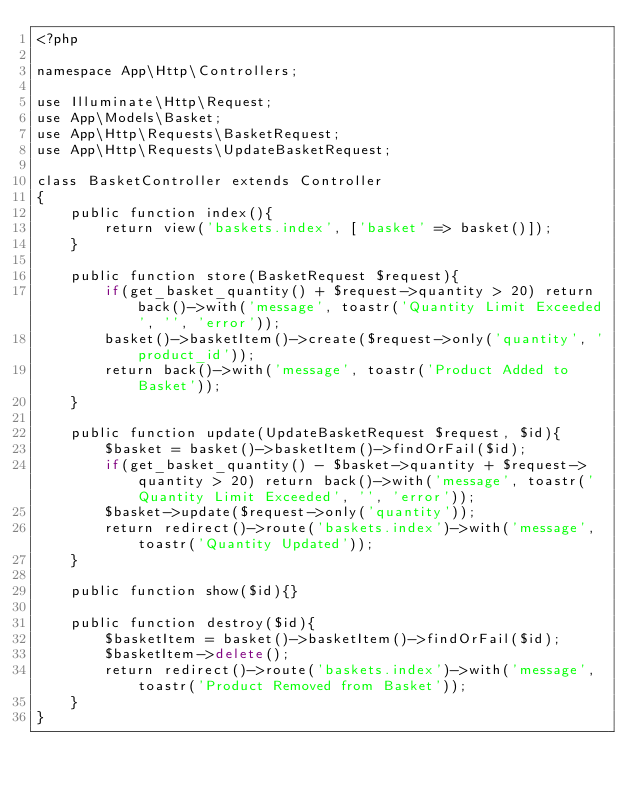<code> <loc_0><loc_0><loc_500><loc_500><_PHP_><?php

namespace App\Http\Controllers;

use Illuminate\Http\Request;
use App\Models\Basket;
use App\Http\Requests\BasketRequest;
use App\Http\Requests\UpdateBasketRequest;

class BasketController extends Controller
{
    public function index(){
        return view('baskets.index', ['basket' => basket()]);
    }

    public function store(BasketRequest $request){
        if(get_basket_quantity() + $request->quantity > 20) return back()->with('message', toastr('Quantity Limit Exceeded', '', 'error'));
        basket()->basketItem()->create($request->only('quantity', 'product_id'));
        return back()->with('message', toastr('Product Added to Basket'));
    }

    public function update(UpdateBasketRequest $request, $id){
        $basket = basket()->basketItem()->findOrFail($id);
        if(get_basket_quantity() - $basket->quantity + $request->quantity > 20) return back()->with('message', toastr('Quantity Limit Exceeded', '', 'error'));
        $basket->update($request->only('quantity'));
        return redirect()->route('baskets.index')->with('message', toastr('Quantity Updated'));
    }

    public function show($id){}

    public function destroy($id){
        $basketItem = basket()->basketItem()->findOrFail($id);
        $basketItem->delete();
        return redirect()->route('baskets.index')->with('message', toastr('Product Removed from Basket'));
    }
}
</code> 